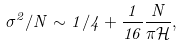Convert formula to latex. <formula><loc_0><loc_0><loc_500><loc_500>\sigma ^ { 2 } / N \sim 1 / 4 + \frac { 1 } { 1 6 } \frac { N } { \pi \mathcal { H } } ,</formula> 